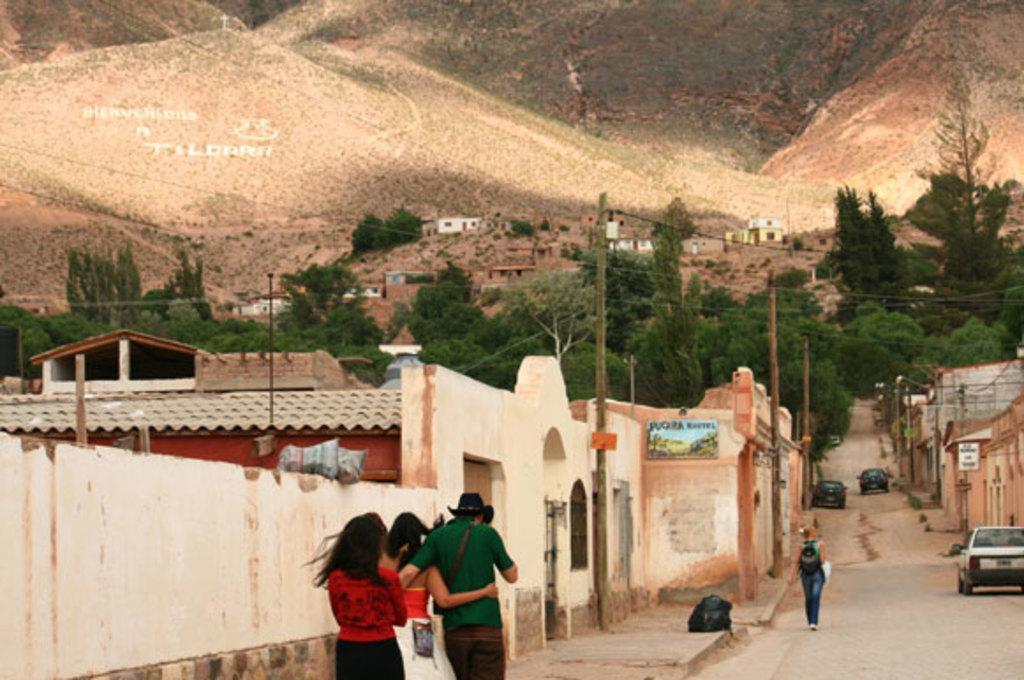How would you summarize this image in a sentence or two? In this image we can see people walking and their cars on the road. In the background there are buildings and trees. At the top there are hills and we can see poles. 